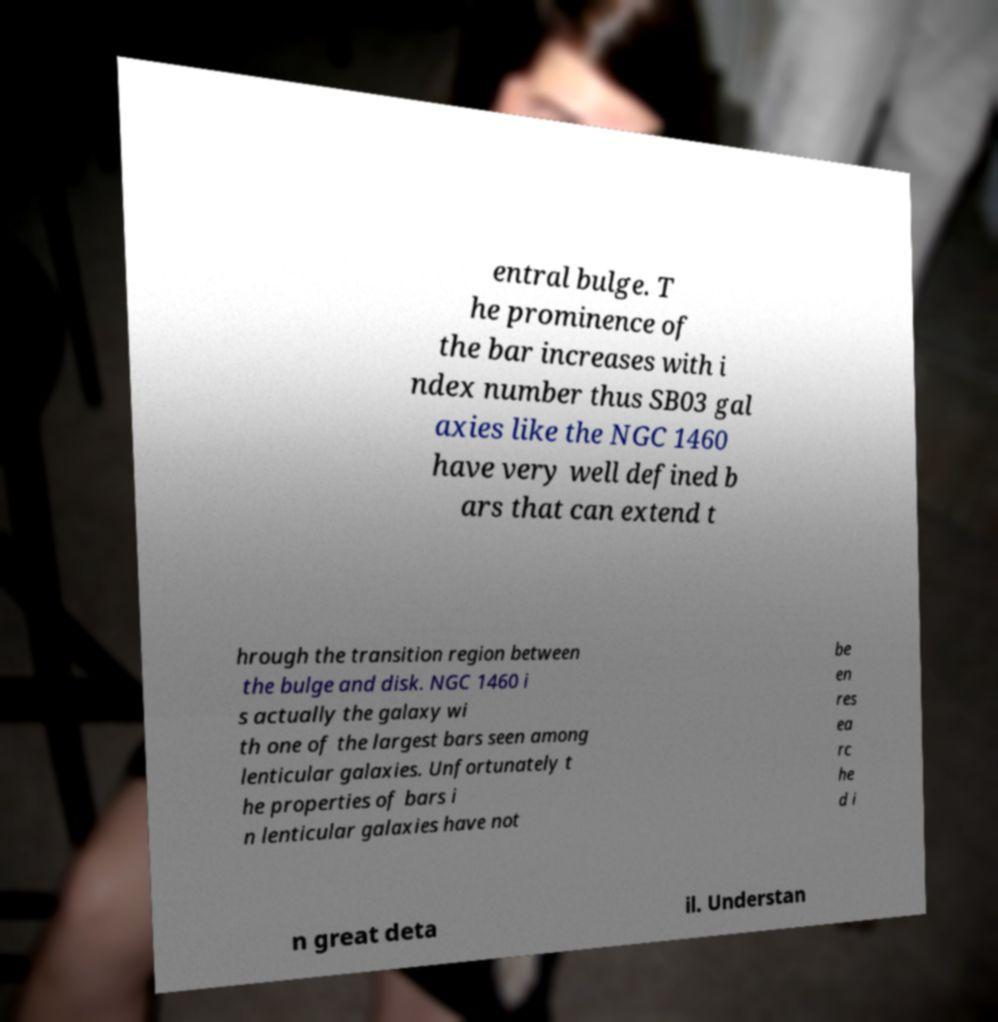I need the written content from this picture converted into text. Can you do that? entral bulge. T he prominence of the bar increases with i ndex number thus SB03 gal axies like the NGC 1460 have very well defined b ars that can extend t hrough the transition region between the bulge and disk. NGC 1460 i s actually the galaxy wi th one of the largest bars seen among lenticular galaxies. Unfortunately t he properties of bars i n lenticular galaxies have not be en res ea rc he d i n great deta il. Understan 